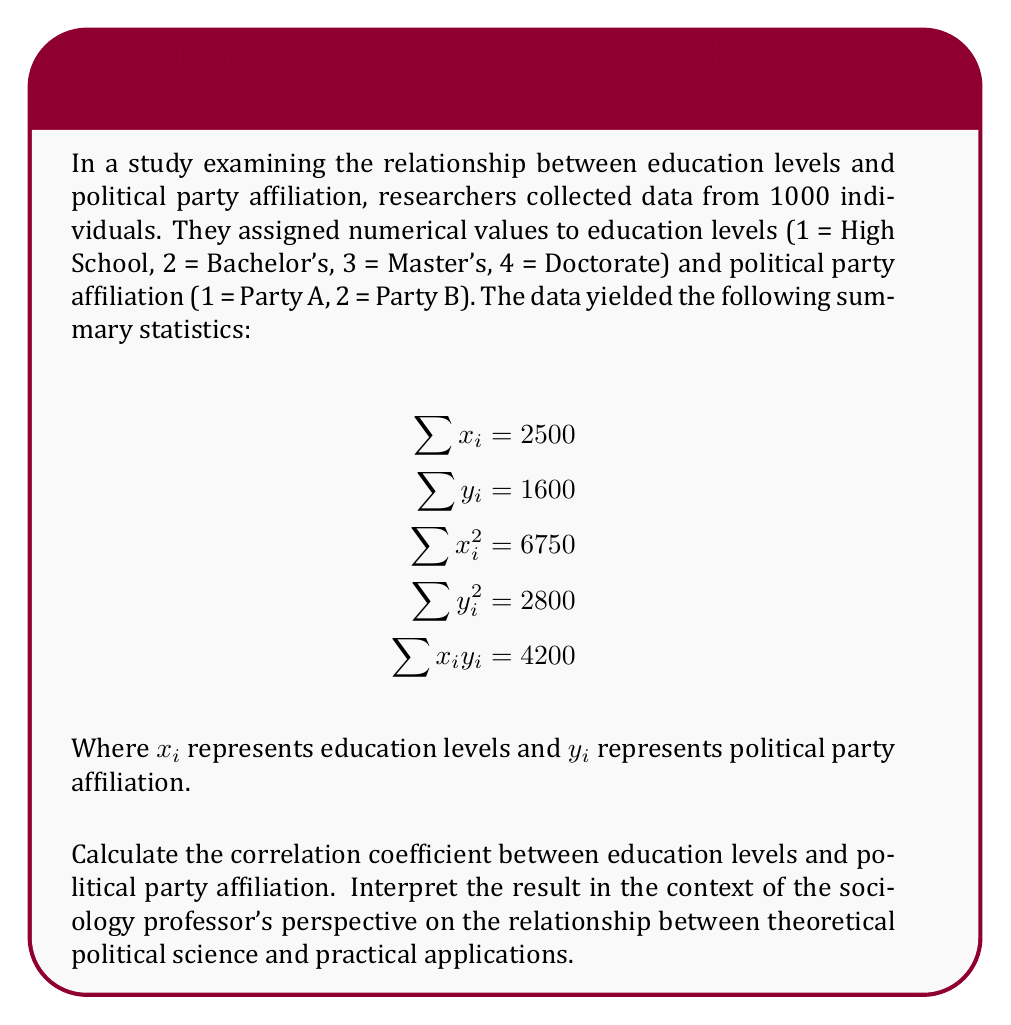Show me your answer to this math problem. To calculate the correlation coefficient, we'll use the formula:

$$r = \frac{n\sum x_iy_i - \sum x_i \sum y_i}{\sqrt{[n\sum x_i^2 - (\sum x_i)^2][n\sum y_i^2 - (\sum y_i)^2]}}$$

Where $n$ is the number of individuals (1000 in this case).

Step 1: Calculate the numerator
$$n\sum x_iy_i - \sum x_i \sum y_i = 1000(4200) - 2500(1600) = 200,000$$

Step 2: Calculate the first term under the square root
$$n\sum x_i^2 - (\sum x_i)^2 = 1000(6750) - 2500^2 = 750,000$$

Step 3: Calculate the second term under the square root
$$n\sum y_i^2 - (\sum y_i)^2 = 1000(2800) - 1600^2 = 240,000$$

Step 4: Multiply the terms under the square root
$$750,000 \times 240,000 = 180,000,000,000$$

Step 5: Take the square root of the product
$$\sqrt{180,000,000,000} = 424,264.07$$

Step 6: Divide the numerator by the denominator
$$r = \frac{200,000}{424,264.07} \approx 0.4714$$

Interpretation: The correlation coefficient of approximately 0.4714 indicates a moderate positive correlation between education levels and political party affiliation. This suggests that as education levels increase, there is a tendency for individuals to align with Party B (represented by higher numerical values).

From the perspective of a sociology professor who believes that emphasis on practical applications diminishes the theoretical importance of political science, this result might be viewed critically. The professor could argue that this quantitative analysis oversimplifies the complex relationship between education and political affiliation, potentially neglecting important theoretical considerations in political science. The focus on a single numerical value (correlation coefficient) might be seen as reducing the nuanced understanding of political behavior to a mere practical application, rather than exploring the deeper theoretical underpinnings of political ideology and its relationship to education.
Answer: $r \approx 0.4714$ 